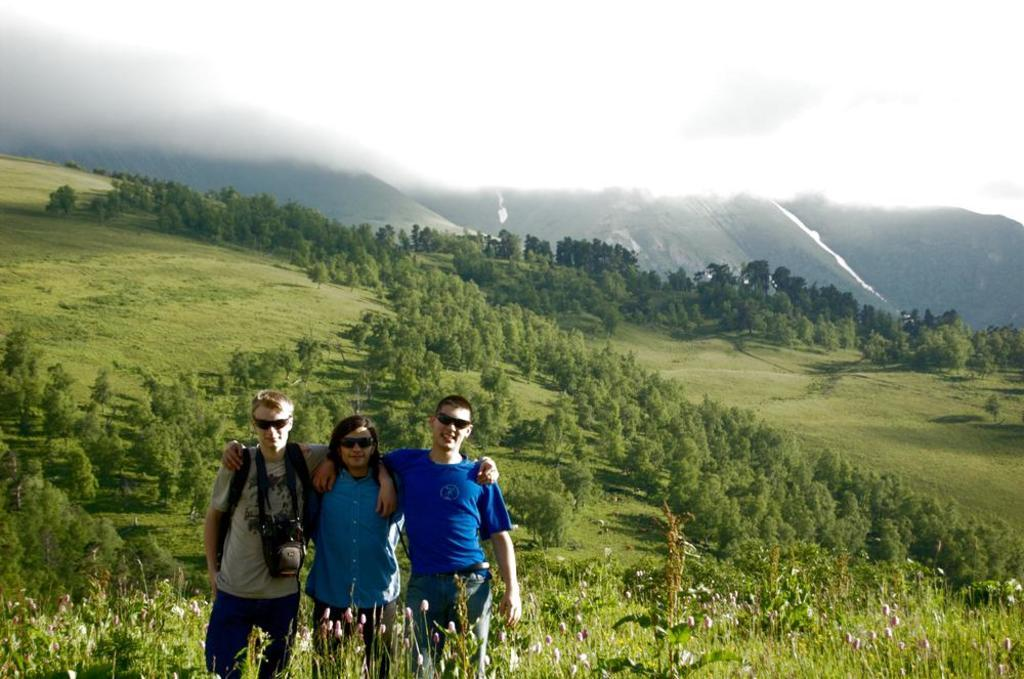How many people are present in the image? There are three people standing in the image. What type of vegetation can be seen in the image? There are plants with flowers, trees, and grass in the image. What is the landscape like in the image? The image features hills in the background. What part of the natural environment is visible in the image? The sky is visible in the image. What type of drawer is being used by the minister in the image? There is no minister or drawer present in the image. How does the grass get washed in the image? The grass does not get washed in the image; it is a static part of the landscape. 